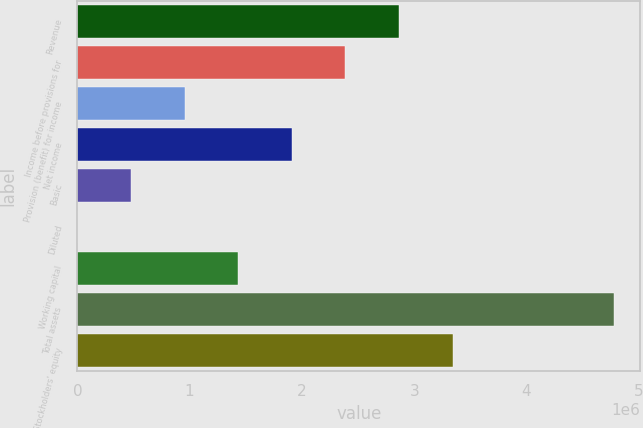Convert chart to OTSL. <chart><loc_0><loc_0><loc_500><loc_500><bar_chart><fcel>Revenue<fcel>Income before provisions for<fcel>Provision (benefit) for income<fcel>Net income<fcel>Basic<fcel>Diluted<fcel>Working capital<fcel>Total assets<fcel>Stockholders' equity<nl><fcel>2.8653e+06<fcel>2.38775e+06<fcel>955101<fcel>1.9102e+06<fcel>477551<fcel>1.64<fcel>1.43265e+06<fcel>4.7755e+06<fcel>3.34285e+06<nl></chart> 